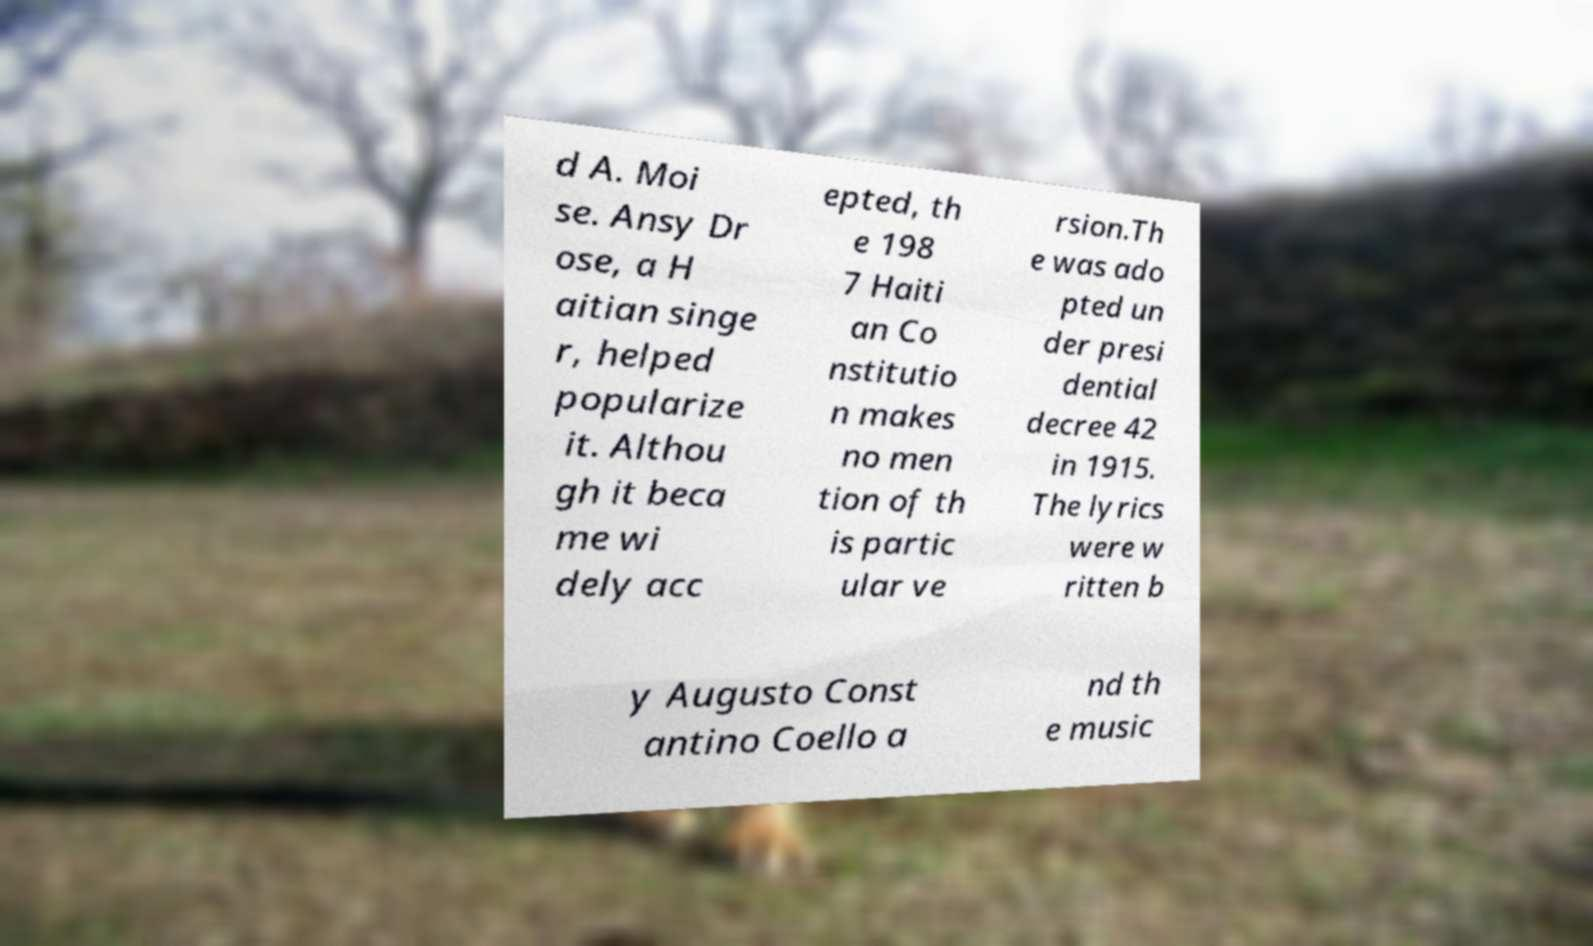Could you extract and type out the text from this image? d A. Moi se. Ansy Dr ose, a H aitian singe r, helped popularize it. Althou gh it beca me wi dely acc epted, th e 198 7 Haiti an Co nstitutio n makes no men tion of th is partic ular ve rsion.Th e was ado pted un der presi dential decree 42 in 1915. The lyrics were w ritten b y Augusto Const antino Coello a nd th e music 